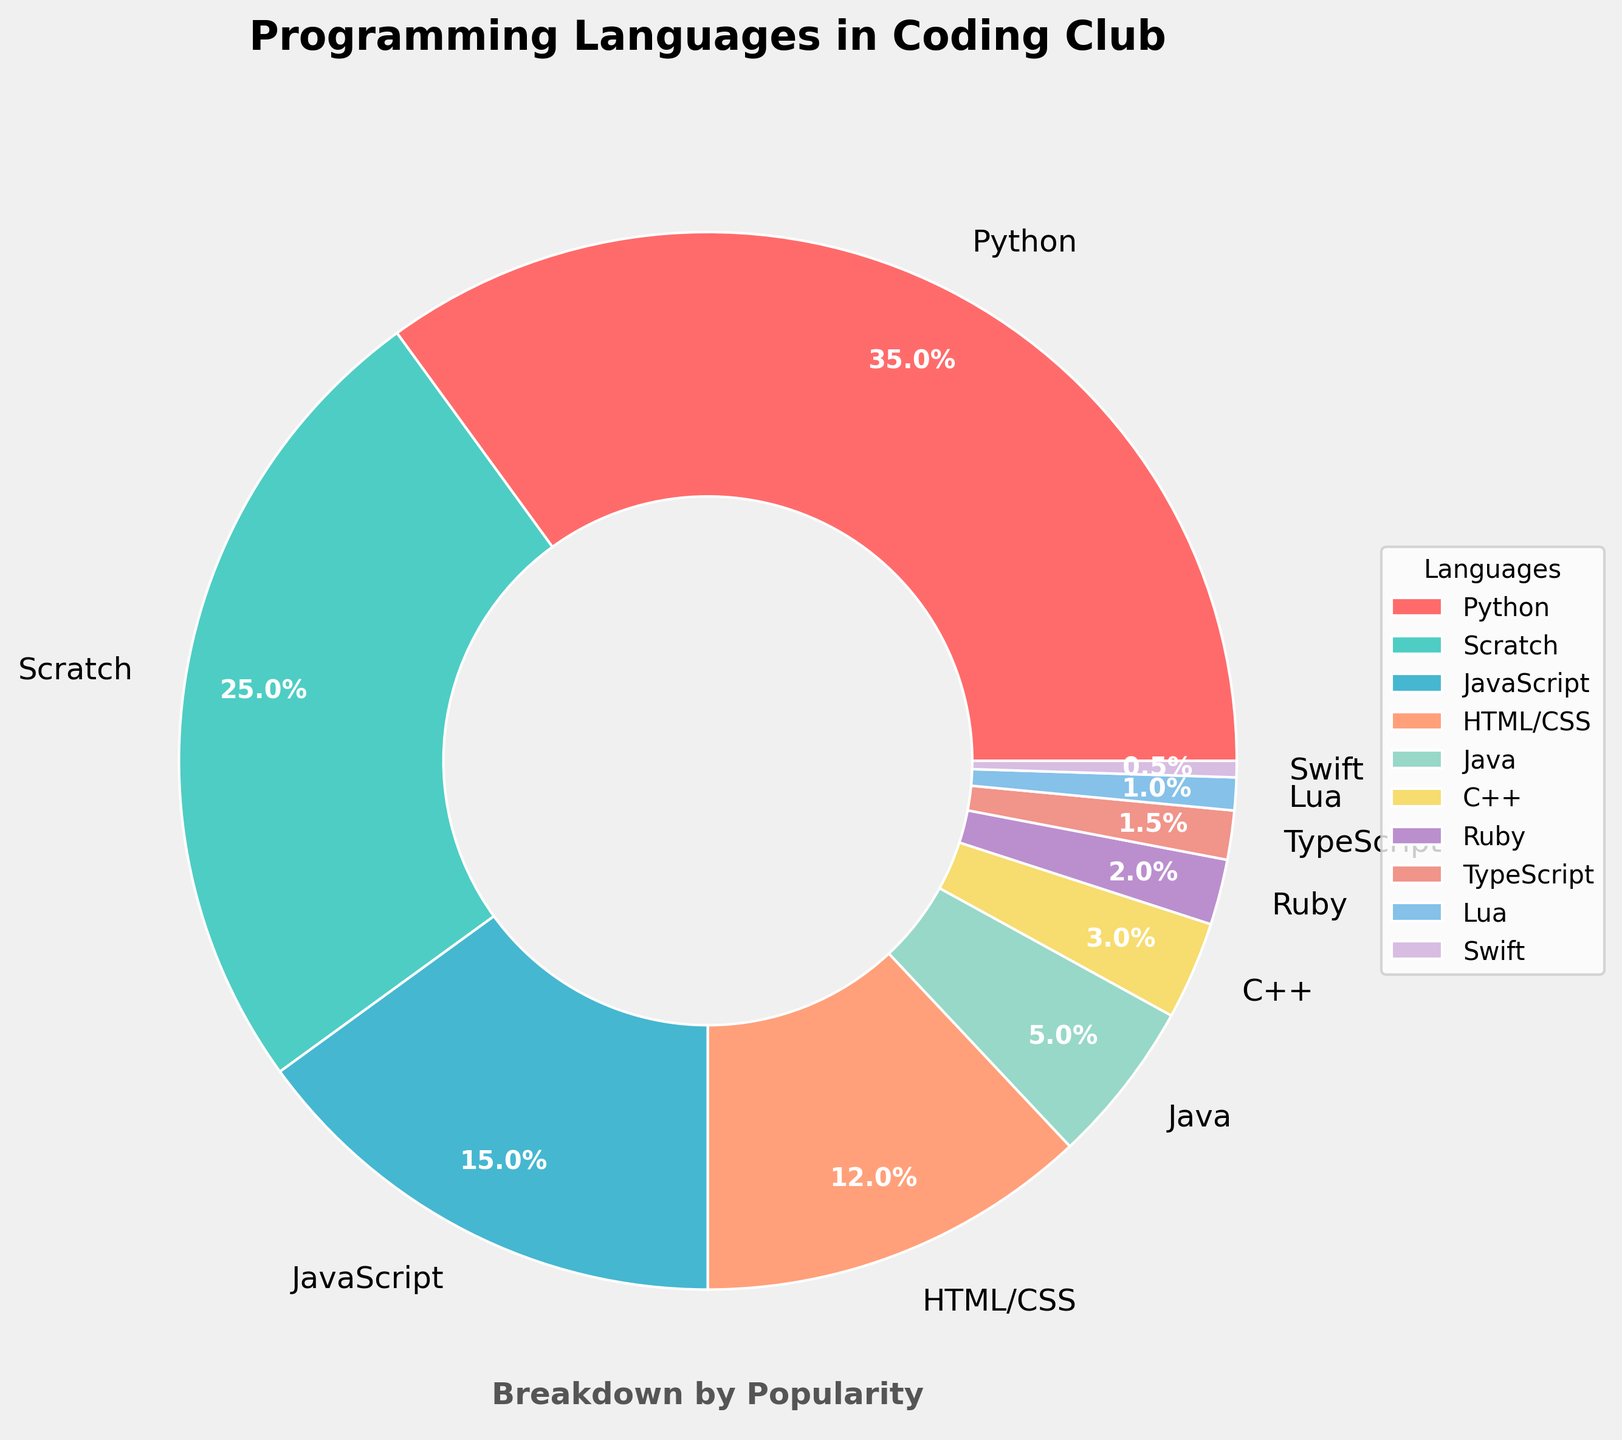What percentage of the languages taught in the coding club are Python and JavaScript combined? Python is 35% and JavaScript is 15%. Adding them together: 35% + 15% = 50%.
Answer: 50% Between Scratch and HTML/CSS, which is more popular and by how much? Scratch is 25% and HTML/CSS is 12%. Subtracting HTML/CSS from Scratch: 25% - 12% = 13%. Scratch is more popular by 13%.
Answer: Scratch by 13% How much more popular is Python compared to Java? Python is 35% and Java is 5%. Subtracting Java from Python: 35% - 5% = 30%. Python is 30% more popular than Java.
Answer: 30% What is the combined percentage of the least popular languages (Ruby, TypeScript, Lua, Swift)? Ruby is 2%, TypeScript is 1.5%, Lua is 1%, and Swift is 0.5%. Adding them together: 2% + 1.5% + 1% + 0.5% = 5%.
Answer: 5% What is the difference in popularity between the most and least popular languages? The most popular is Python at 35%, and the least popular is Swift at 0.5%. Subtracting Swift from Python: 35% - 0.5% = 34.5%.
Answer: 34.5% Which language is represented by the teal color? The language represented by the teal color is Scratch.
Answer: Scratch Out of HTML/CSS and JavaScript, which language is less popular and by what percentage? HTML/CSS is 12% and JavaScript is 15%. Subtracting HTML/CSS from JavaScript: 15% - 12% = 3%. HTML/CSS is 3% less popular.
Answer: HTML/CSS by 3% What’s the total percentage for the top three most popular languages? The top three most popular languages are Python (35%), Scratch (25%), and JavaScript (15%). Adding them together: 35% + 25% + 15% = 75%.
Answer: 75% Compare the popularity of C++ and Lua, which is more popular and by how much? C++ is 3% and Lua is 1%. Subtracting Lua from C++: 3% - 1% = 2%. C++ is more popular by 2%.
Answer: C++ by 2% How does the popularity of HTML/CSS compare to that of Java and Ruby combined? HTML/CSS is 12%, Java is 5%, and Ruby is 2%. Adding Java and Ruby: 5% + 2% = 7%. HTML/CSS is more popular than Java and Ruby combined by 12% - 7% = 5%.
Answer: HTML/CSS by 5% 